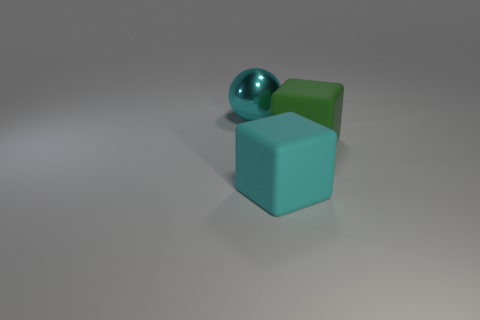Can you describe the lighting and mood conveyed by the image? The image has a soft, diffuse lighting that creates subtle shadows and gives the scene a calm and serene mood. There is no harsh light or dramatic contrast, which gives the image a neutral or even somewhat clinical atmosphere, highlighting the shapes and their material properties without strong emotional undertones. 